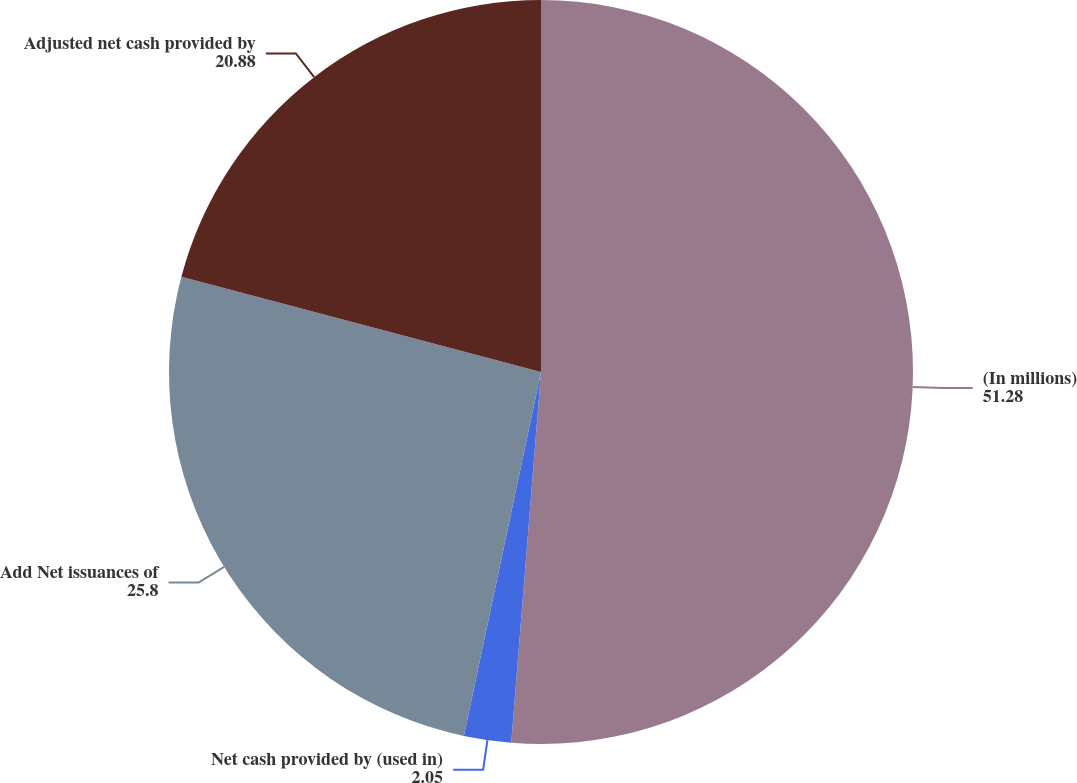Convert chart to OTSL. <chart><loc_0><loc_0><loc_500><loc_500><pie_chart><fcel>(In millions)<fcel>Net cash provided by (used in)<fcel>Add Net issuances of<fcel>Adjusted net cash provided by<nl><fcel>51.28%<fcel>2.05%<fcel>25.8%<fcel>20.88%<nl></chart> 